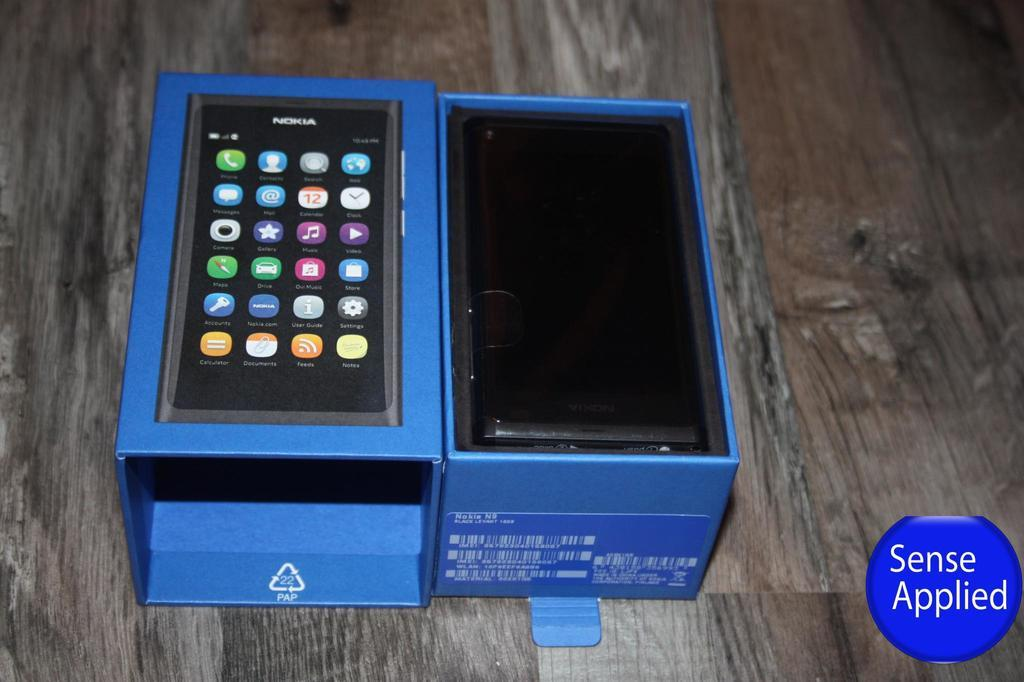<image>
Summarize the visual content of the image. a blue nokia phone box with a logo on the bottom right of the screen that says 'sense applied' 